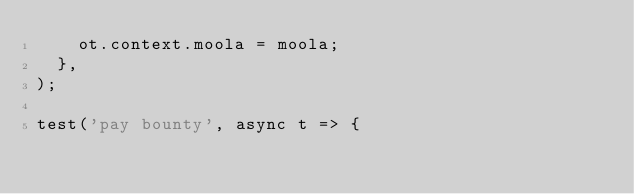Convert code to text. <code><loc_0><loc_0><loc_500><loc_500><_JavaScript_>    ot.context.moola = moola;
  },
);

test('pay bounty', async t => {</code> 